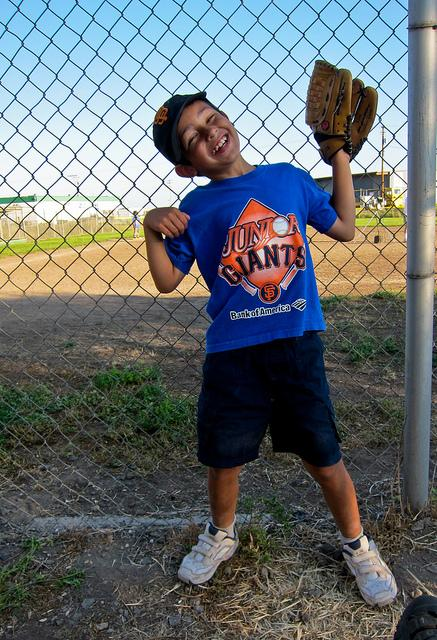What is on the boy's hand?

Choices:
A) glove
B) tattoo
C) caterpillar
D) egg yolk glove 